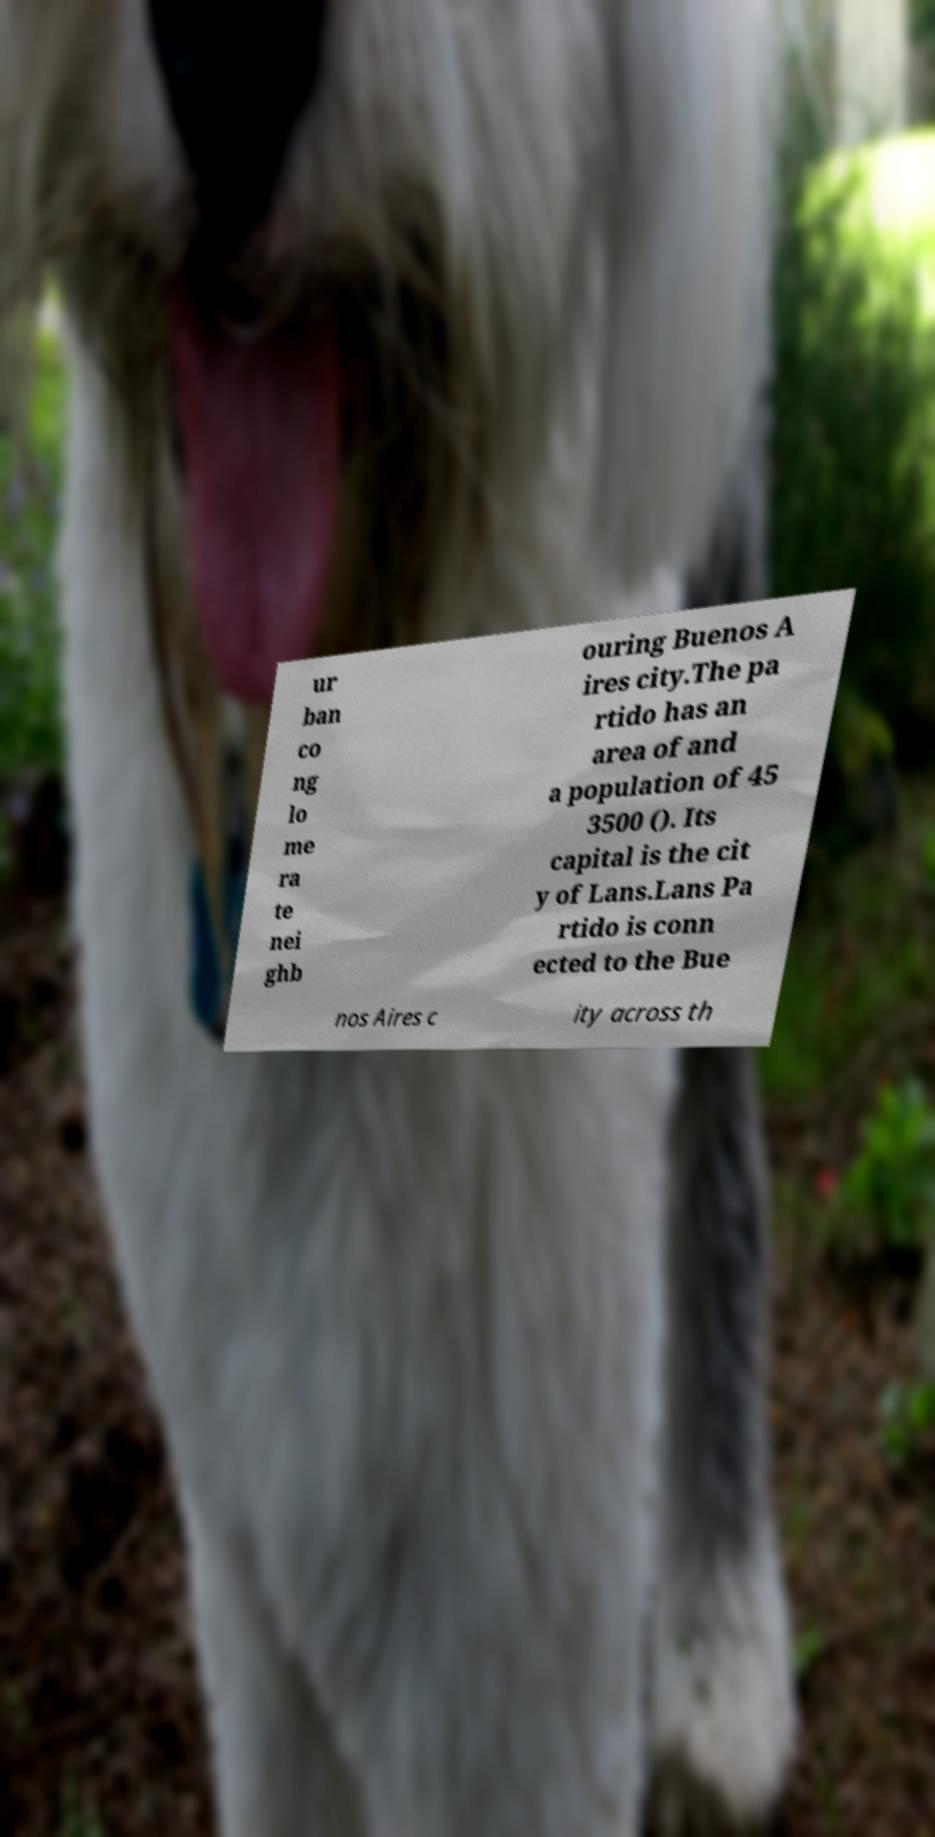What messages or text are displayed in this image? I need them in a readable, typed format. ur ban co ng lo me ra te nei ghb ouring Buenos A ires city.The pa rtido has an area of and a population of 45 3500 (). Its capital is the cit y of Lans.Lans Pa rtido is conn ected to the Bue nos Aires c ity across th 